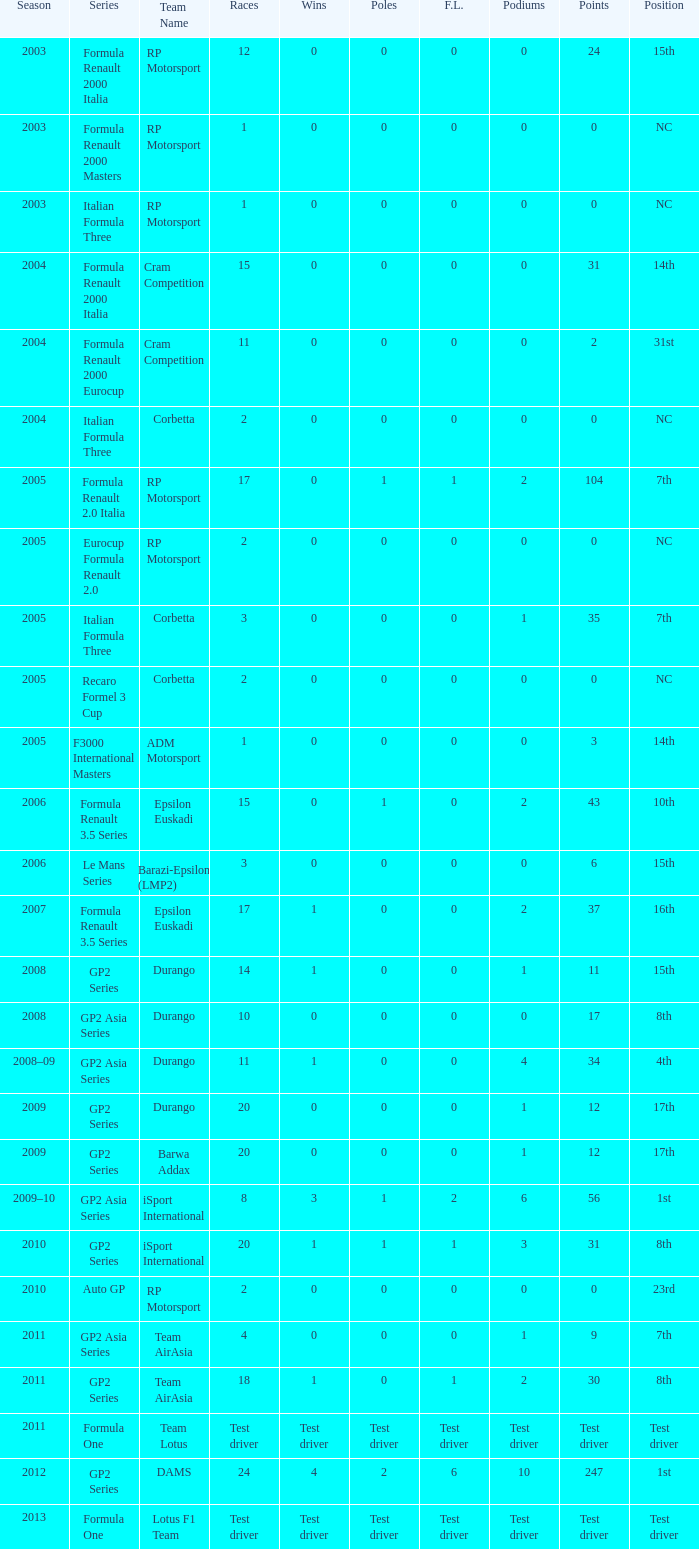What is the number of podiums with 0 wins, 0 F.L. and 35 points? 1.0. 